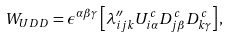Convert formula to latex. <formula><loc_0><loc_0><loc_500><loc_500>W _ { U D D } = \epsilon ^ { \alpha \beta \gamma } \left [ \lambda ^ { \prime \prime } _ { i j k } U ^ { c } _ { i \alpha } D ^ { c } _ { j \beta } D ^ { c } _ { k \gamma } \right ] ,</formula> 